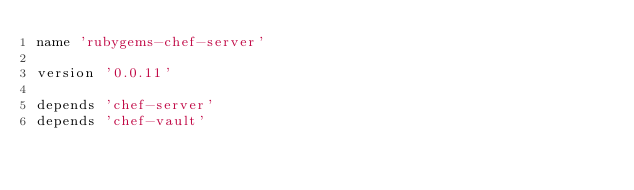Convert code to text. <code><loc_0><loc_0><loc_500><loc_500><_Ruby_>name 'rubygems-chef-server'

version '0.0.11'

depends 'chef-server'
depends 'chef-vault'
</code> 